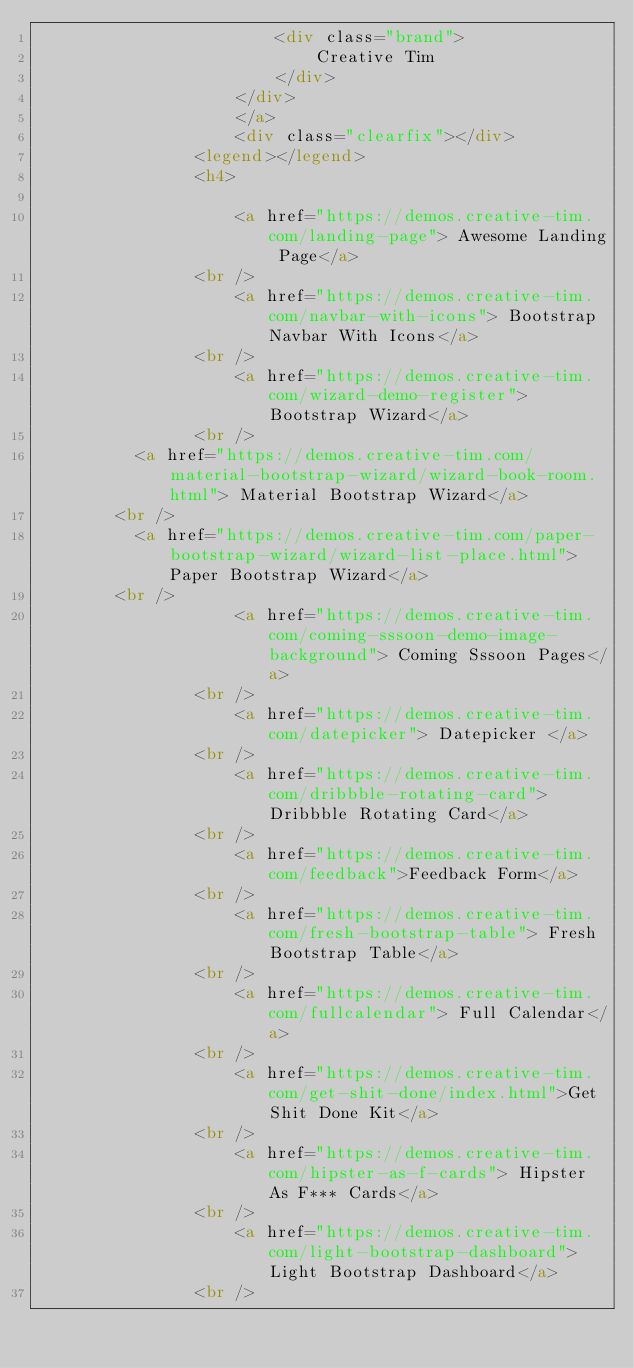<code> <loc_0><loc_0><loc_500><loc_500><_HTML_>                        <div class="brand">
                            Creative Tim
                        </div>
                    </div>
                    </a>
                    <div class="clearfix"></div>
                <legend></legend>
                <h4>

                    <a href="https://demos.creative-tim.com/landing-page"> Awesome Landing Page</a>
                <br />
                    <a href="https://demos.creative-tim.com/navbar-with-icons"> Bootstrap Navbar With Icons</a>
                <br />
                    <a href="https://demos.creative-tim.com/wizard-demo-register"> Bootstrap Wizard</a>
                <br />
					<a href="https://demos.creative-tim.com/material-bootstrap-wizard/wizard-book-room.html"> Material Bootstrap Wizard</a>
				<br />
					<a href="https://demos.creative-tim.com/paper-bootstrap-wizard/wizard-list-place.html"> Paper Bootstrap Wizard</a>
				<br />
                    <a href="https://demos.creative-tim.com/coming-sssoon-demo-image-background"> Coming Sssoon Pages</a>
                <br />
                    <a href="https://demos.creative-tim.com/datepicker"> Datepicker </a>
                <br />
                    <a href="https://demos.creative-tim.com/dribbble-rotating-card"> Dribbble Rotating Card</a>
                <br />
                    <a href="https://demos.creative-tim.com/feedback">Feedback Form</a>
                <br />
                    <a href="https://demos.creative-tim.com/fresh-bootstrap-table"> Fresh Bootstrap Table</a>
                <br />
                    <a href="https://demos.creative-tim.com/fullcalendar"> Full Calendar</a>
                <br />
                    <a href="https://demos.creative-tim.com/get-shit-done/index.html">Get Shit Done Kit</a>
                <br />
                    <a href="https://demos.creative-tim.com/hipster-as-f-cards"> Hipster As F*** Cards</a>
                <br />
                    <a href="https://demos.creative-tim.com/light-bootstrap-dashboard"> Light Bootstrap Dashboard</a>
                <br /></code> 